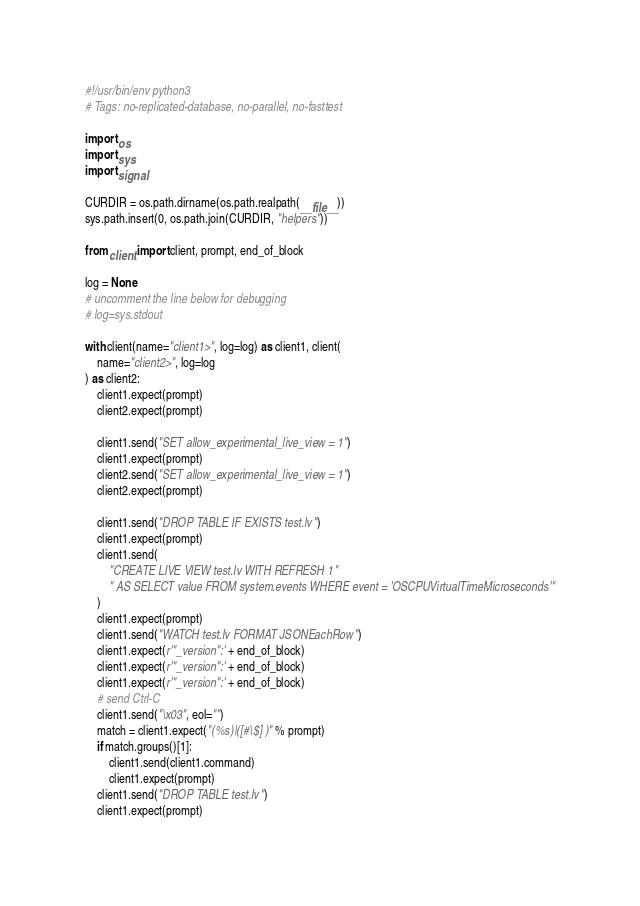Convert code to text. <code><loc_0><loc_0><loc_500><loc_500><_Python_>#!/usr/bin/env python3
# Tags: no-replicated-database, no-parallel, no-fasttest

import os
import sys
import signal

CURDIR = os.path.dirname(os.path.realpath(__file__))
sys.path.insert(0, os.path.join(CURDIR, "helpers"))

from client import client, prompt, end_of_block

log = None
# uncomment the line below for debugging
# log=sys.stdout

with client(name="client1>", log=log) as client1, client(
    name="client2>", log=log
) as client2:
    client1.expect(prompt)
    client2.expect(prompt)

    client1.send("SET allow_experimental_live_view = 1")
    client1.expect(prompt)
    client2.send("SET allow_experimental_live_view = 1")
    client2.expect(prompt)

    client1.send("DROP TABLE IF EXISTS test.lv")
    client1.expect(prompt)
    client1.send(
        "CREATE LIVE VIEW test.lv WITH REFRESH 1"
        " AS SELECT value FROM system.events WHERE event = 'OSCPUVirtualTimeMicroseconds'"
    )
    client1.expect(prompt)
    client1.send("WATCH test.lv FORMAT JSONEachRow")
    client1.expect(r'"_version":' + end_of_block)
    client1.expect(r'"_version":' + end_of_block)
    client1.expect(r'"_version":' + end_of_block)
    # send Ctrl-C
    client1.send("\x03", eol="")
    match = client1.expect("(%s)|([#\$] )" % prompt)
    if match.groups()[1]:
        client1.send(client1.command)
        client1.expect(prompt)
    client1.send("DROP TABLE test.lv")
    client1.expect(prompt)
</code> 